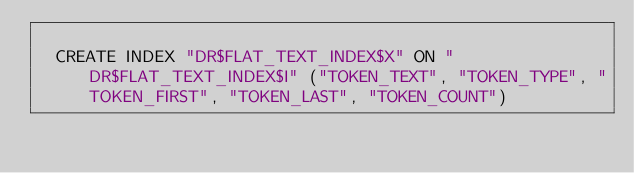<code> <loc_0><loc_0><loc_500><loc_500><_SQL_>
  CREATE INDEX "DR$FLAT_TEXT_INDEX$X" ON "DR$FLAT_TEXT_INDEX$I" ("TOKEN_TEXT", "TOKEN_TYPE", "TOKEN_FIRST", "TOKEN_LAST", "TOKEN_COUNT") 
  </code> 